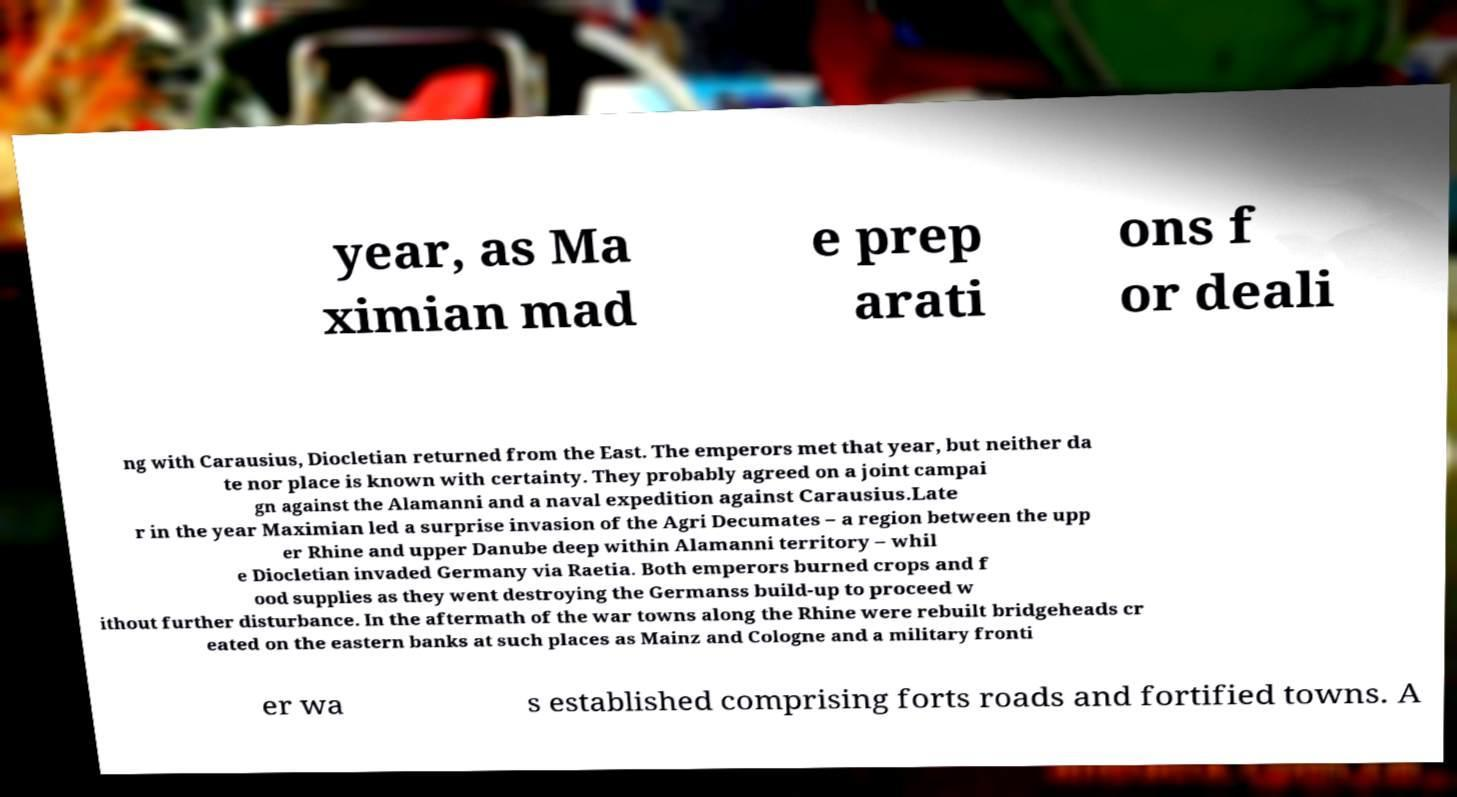There's text embedded in this image that I need extracted. Can you transcribe it verbatim? year, as Ma ximian mad e prep arati ons f or deali ng with Carausius, Diocletian returned from the East. The emperors met that year, but neither da te nor place is known with certainty. They probably agreed on a joint campai gn against the Alamanni and a naval expedition against Carausius.Late r in the year Maximian led a surprise invasion of the Agri Decumates – a region between the upp er Rhine and upper Danube deep within Alamanni territory – whil e Diocletian invaded Germany via Raetia. Both emperors burned crops and f ood supplies as they went destroying the Germanss build-up to proceed w ithout further disturbance. In the aftermath of the war towns along the Rhine were rebuilt bridgeheads cr eated on the eastern banks at such places as Mainz and Cologne and a military fronti er wa s established comprising forts roads and fortified towns. A 